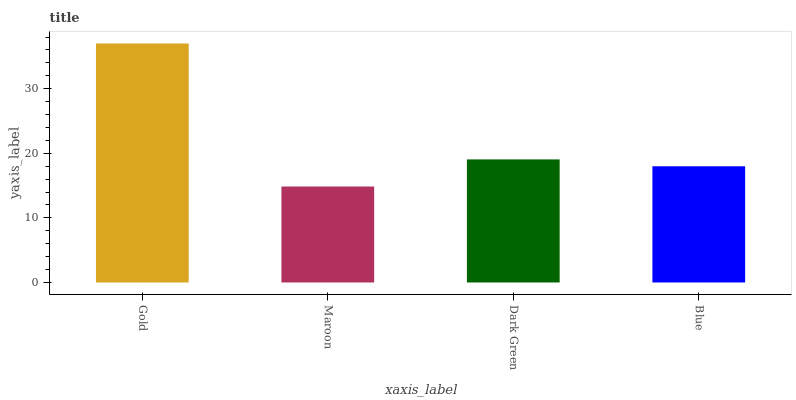Is Maroon the minimum?
Answer yes or no. Yes. Is Gold the maximum?
Answer yes or no. Yes. Is Dark Green the minimum?
Answer yes or no. No. Is Dark Green the maximum?
Answer yes or no. No. Is Dark Green greater than Maroon?
Answer yes or no. Yes. Is Maroon less than Dark Green?
Answer yes or no. Yes. Is Maroon greater than Dark Green?
Answer yes or no. No. Is Dark Green less than Maroon?
Answer yes or no. No. Is Dark Green the high median?
Answer yes or no. Yes. Is Blue the low median?
Answer yes or no. Yes. Is Blue the high median?
Answer yes or no. No. Is Dark Green the low median?
Answer yes or no. No. 